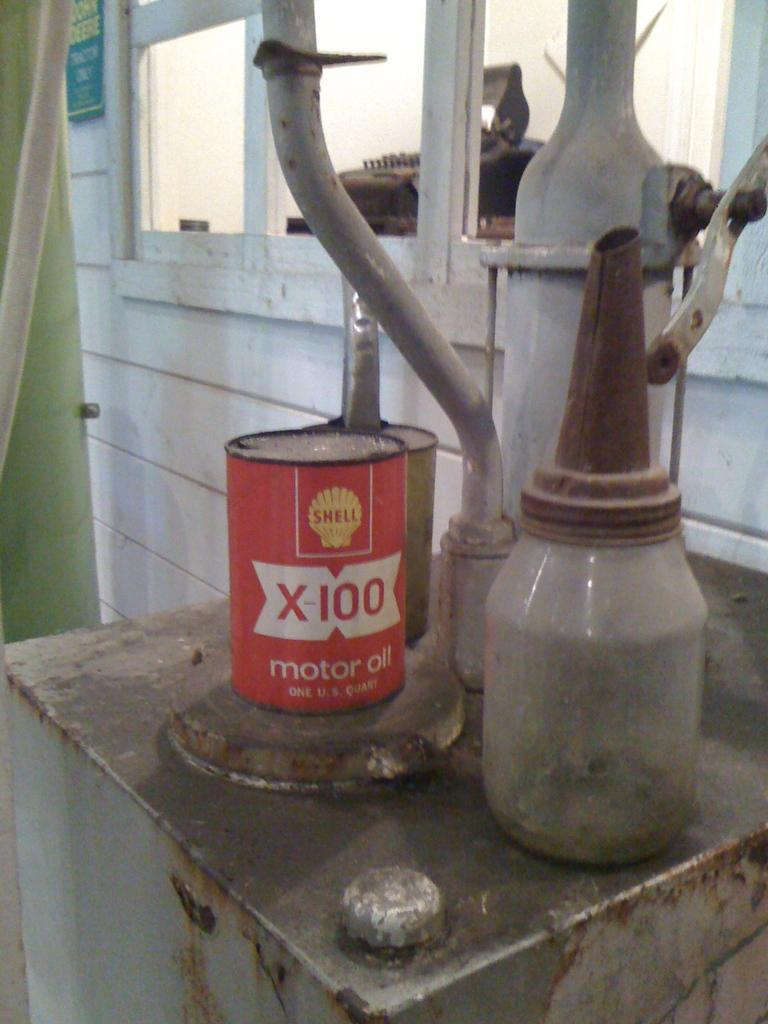Provide a one-sentence caption for the provided image. A one U.S. quart can of Shell X-100 motor oil is on the rusty table. 